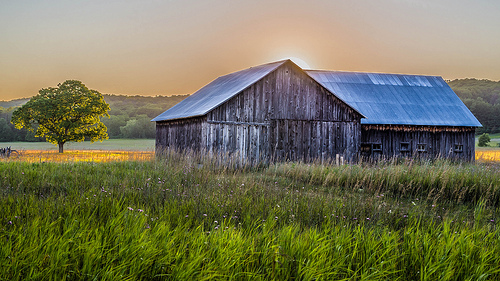<image>
Can you confirm if the tree is next to the lake? Yes. The tree is positioned adjacent to the lake, located nearby in the same general area. 